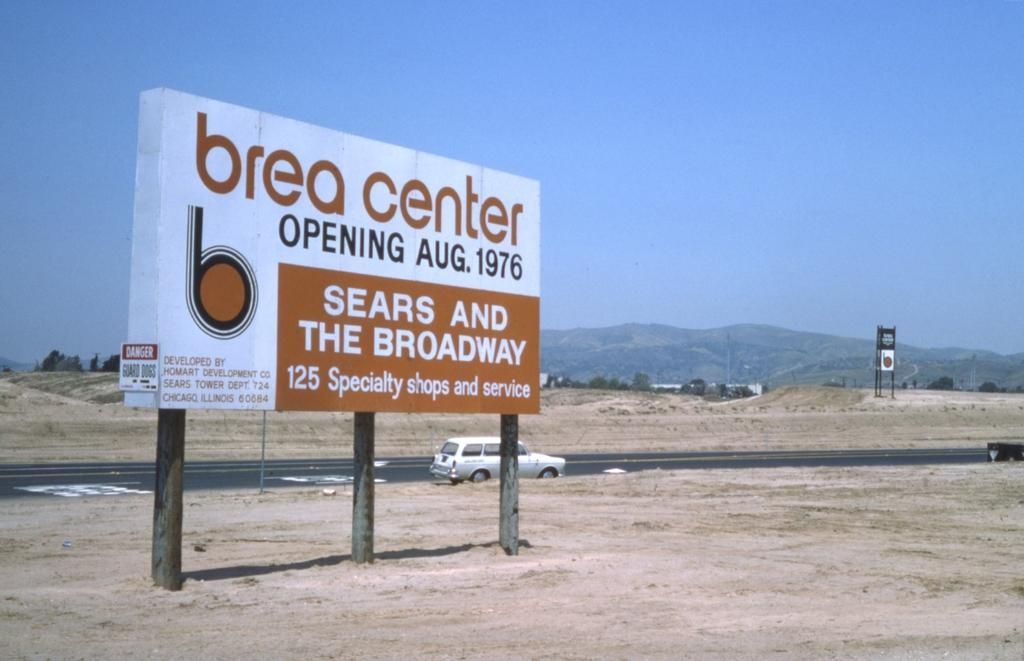<image>
Present a compact description of the photo's key features. An advertisement for the Brea Center in the middle of the desert on a clear day. 